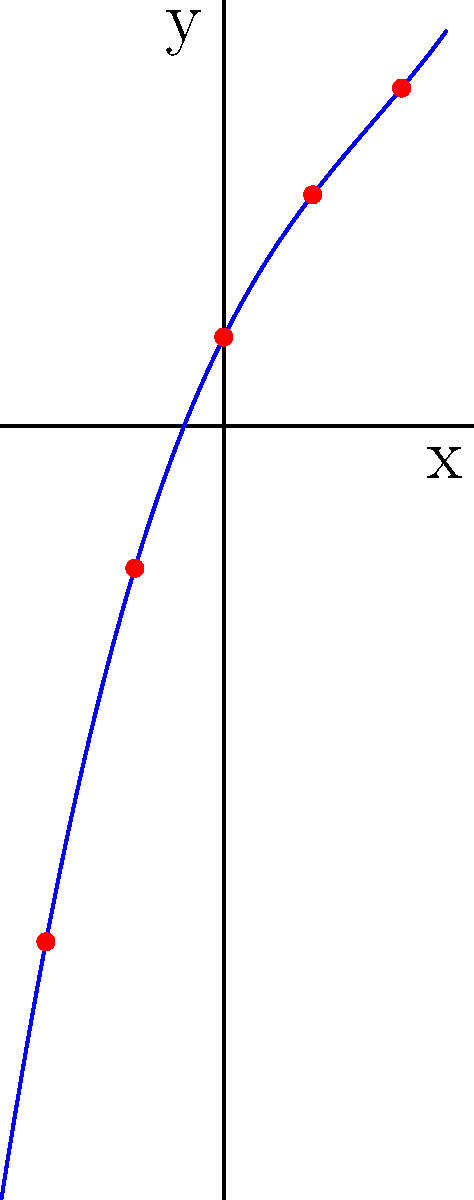Dado o conjunto de pontos $\{(-2, -1.1), (-1, 2.6), (0, 1), (1, 2.6), (2, 5.1)\}$, determine o polinômio interpolador de grau mínimo que passa por todos esses pontos. Qual é a complexidade computacional do método mais eficiente para resolver este problema? Para resolver este problema de forma eficiente, podemos usar o método de interpolação de Lagrange. Vamos seguir os passos:

1) O polinômio interpolador terá grau no máximo 4, pois temos 5 pontos.

2) A fórmula geral do polinômio de Lagrange é:

   $$P(x) = \sum_{i=0}^{n} y_i \cdot L_i(x)$$

   onde $L_i(x)$ são os polinômios de Lagrange:

   $$L_i(x) = \prod_{j=0, j\neq i}^{n} \frac{x - x_j}{x_i - x_j}$$

3) Calculando os polinômios de Lagrange para cada ponto:

   $L_0(x) = \frac{(x+1)(x)(x-1)(x-2)}{(-1)(2)(3)(4)}$
   $L_1(x) = \frac{(x+2)(x)(x-1)(x-2)}{(1)(3)(2)(3)}$
   $L_2(x) = \frac{(x+2)(x+1)(x-1)(x-2)}{(2)(1)(1)(2)}$
   $L_3(x) = \frac{(x+2)(x+1)(x)(x-2)}{(3)(2)(1)(1)}$
   $L_4(x) = \frac{(x+2)(x+1)(x)(x-1)}{(4)(3)(2)(1)}$

4) O polinômio interpolador é:

   $$P(x) = -1.1L_0(x) + 2.6L_1(x) + 1L_2(x) + 2.6L_3(x) + 5.1L_4(x)$$

5) Simplificando, obtemos:

   $$P(x) = 0.1x^3 - 0.5x^2 + 2x + 1$$

6) A complexidade computacional do método de Lagrange é $O(n^2)$, onde n é o número de pontos. Este é o método mais eficiente para pequenos conjuntos de pontos.

Para conjuntos maiores, outros métodos como o de Newton ou técnicas de álgebra linear podem ser mais eficientes, com complexidade $O(n \log n)$ ou $O(n)$ em casos especiais.
Answer: $P(x) = 0.1x^3 - 0.5x^2 + 2x + 1$; Complexidade: $O(n^2)$ 